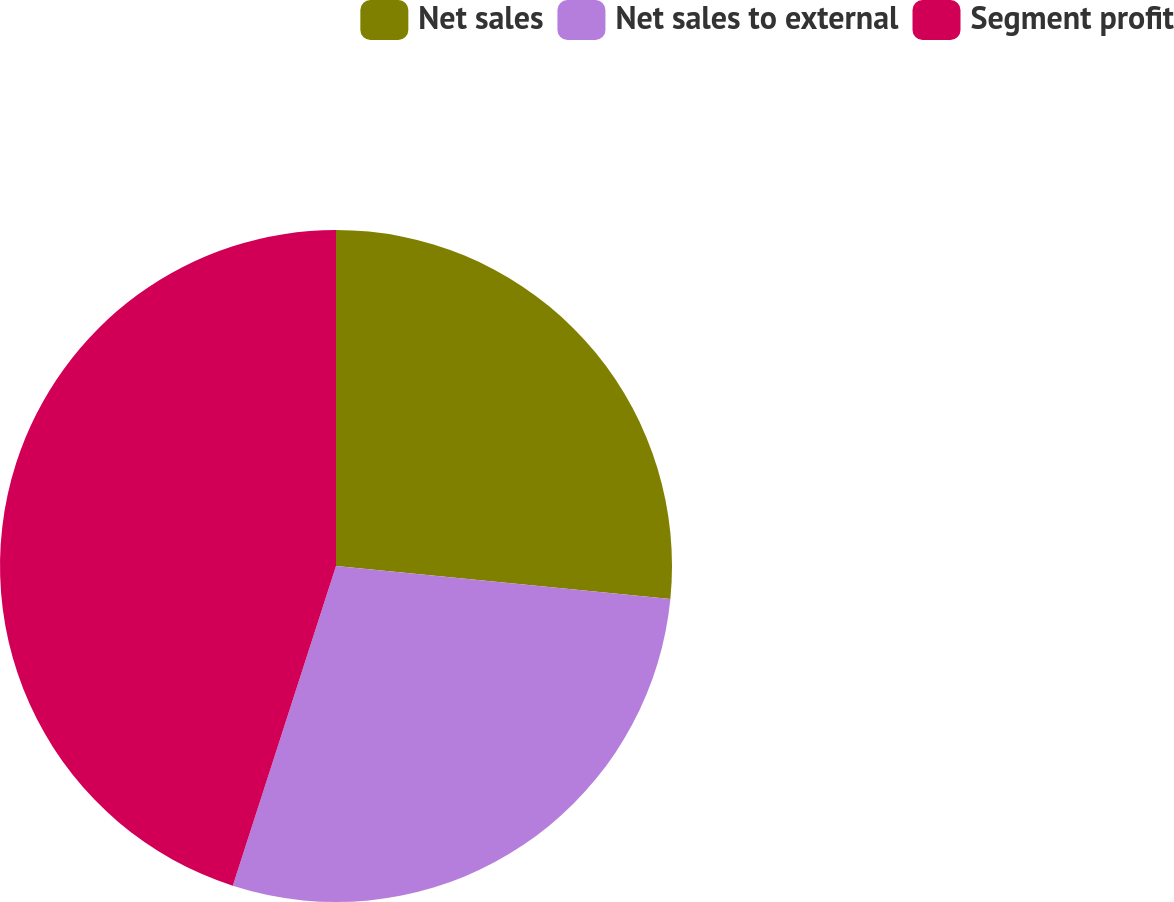<chart> <loc_0><loc_0><loc_500><loc_500><pie_chart><fcel>Net sales<fcel>Net sales to external<fcel>Segment profit<nl><fcel>26.56%<fcel>28.41%<fcel>45.03%<nl></chart> 